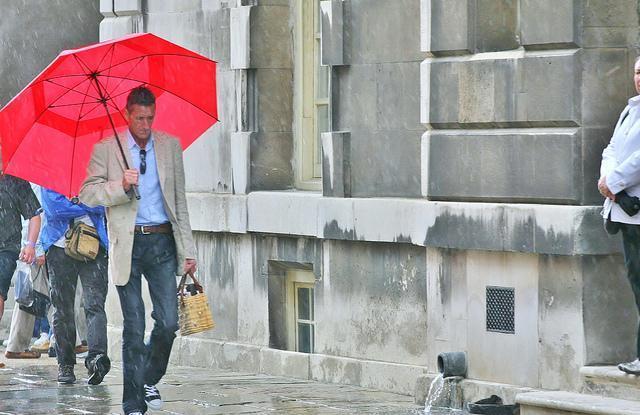How many people are in the picture?
Give a very brief answer. 5. How many umbrellas are there?
Give a very brief answer. 1. How many baby elephants are there?
Give a very brief answer. 0. 